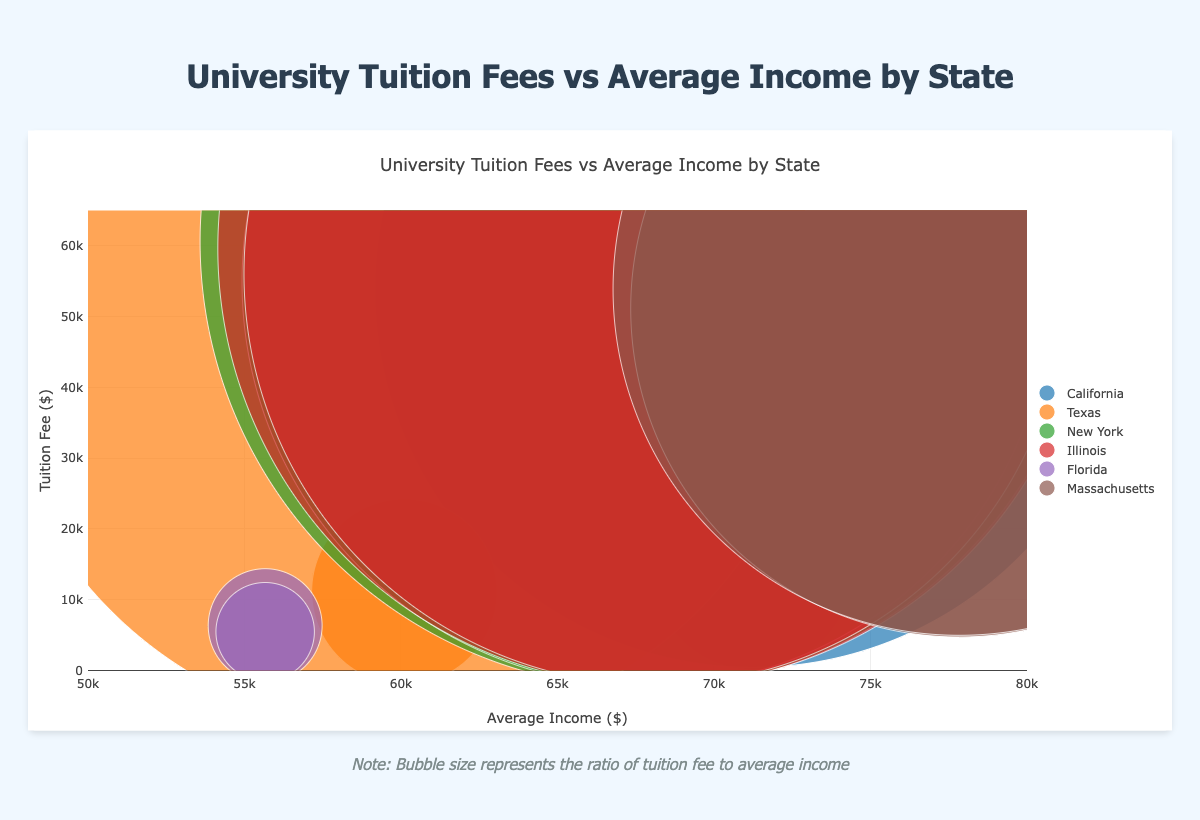What are the tuition fee ranges for universities in Florida? To find the tuition fee ranges for universities in Florida, locate the points representing universities from Florida (University of Florida and Florida State University) on the y-axis, which shows their tuition fees. University of Florida has a fee of $6,340 and Florida State University has a fee of $5,479. So, the tuition fees in Florida range from $5,479 to $6,340.
Answer: $5,479 to $6,340 Which state has the highest average income? Identify the x-axis, which represents the average income for each university. Scan for the highest value. Massachusetts has the highest average income of $77,835.
Answer: Massachusetts Which university has the highest tuition fee in New York? Look at the data points in New York and compare their y-axis values (tuition fees). Columbia University has the highest tuition fee in New York at $60,578.
Answer: Columbia University How does the tuition fee of the University of Texas at Austin compare to Rice University? Locate both the University of Texas at Austin and Rice University on the y-axis (tuition fee) and compare their values. The University of Texas at Austin has a tuition fee of $11,152, which is significantly lower than Rice University's fee of $49,917.
Answer: Rice University’s fee is higher What is the bubble size representing? Refer to the note provided below the chart, which explains that the bubble size represents the ratio of tuition fee to average income.
Answer: Ratio of tuition fee to average income Which university has the smallest bubble size in the figure, and what does that indicate? Identify the smallest bubble in the chart. For the university with the smallest bubble, use the note explaining bubble size. Florida State University has the smallest bubble size, indicating it has the lowest ratio of tuition fee to average income.
Answer: Florida State University, lowest ratio How many universities in the figure have a tuition fee above $50,000? Count the data points on the y-axis above the $50,000 mark. Universities with tuition fees above $50,000 are: Stanford University, Rice University, Columbia University, New York University, University of Chicago, Northwestern University, Harvard University, and MIT. There are 8 universities in total.
Answer: 8 Compare the tuition fees of Harvard University and MIT. Locate Harvard University and MIT on the y-axis (tuition fees). Harvard University has a tuition fee of $51,143, whereas MIT has a tuition fee of $53,890. MIT's tuition is higher.
Answer: MIT's fee is higher Is the average income for universities in California higher or lower than in Texas? Compare the average income values on the x-axis for California (Stanford University and University of California, Berkeley) and Texas (University of Texas at Austin and Rice University). California's average income is $71,228, and Texas's average income is $60,109.
Answer: Higher in California Which university has a tuition fee closest to $60,000, and what is the state? Scan the y-axis around the $60,000 mark. Columbia University in New York has a tuition fee of $60,578, the closest to $60,000.
Answer: Columbia University in New York 